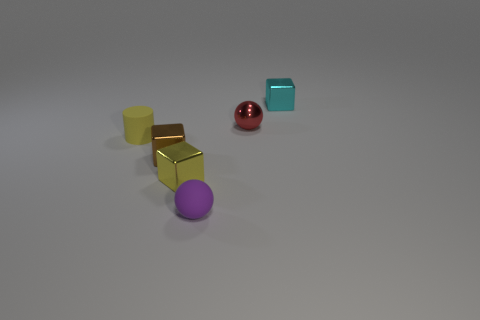What material is the yellow block that is the same size as the cylinder?
Your answer should be compact. Metal. Is there a small cyan block on the right side of the tiny block behind the rubber thing that is behind the small rubber sphere?
Your response must be concise. No. Is there any other thing that has the same shape as the small brown object?
Make the answer very short. Yes. There is a small cube that is behind the tiny brown object; is its color the same as the tiny ball that is in front of the tiny red object?
Offer a terse response. No. Are there any cyan things?
Your answer should be compact. Yes. There is a tiny thing that is the same color as the tiny cylinder; what is its material?
Your answer should be compact. Metal. What size is the metallic cube to the right of the tiny ball that is in front of the small ball behind the small rubber sphere?
Your answer should be compact. Small. There is a yellow metallic object; does it have the same shape as the matte object that is in front of the brown object?
Your answer should be very brief. No. Is there a big rubber cube of the same color as the small matte ball?
Offer a terse response. No. How many cylinders are either small brown objects or tiny yellow metal things?
Your response must be concise. 0. 